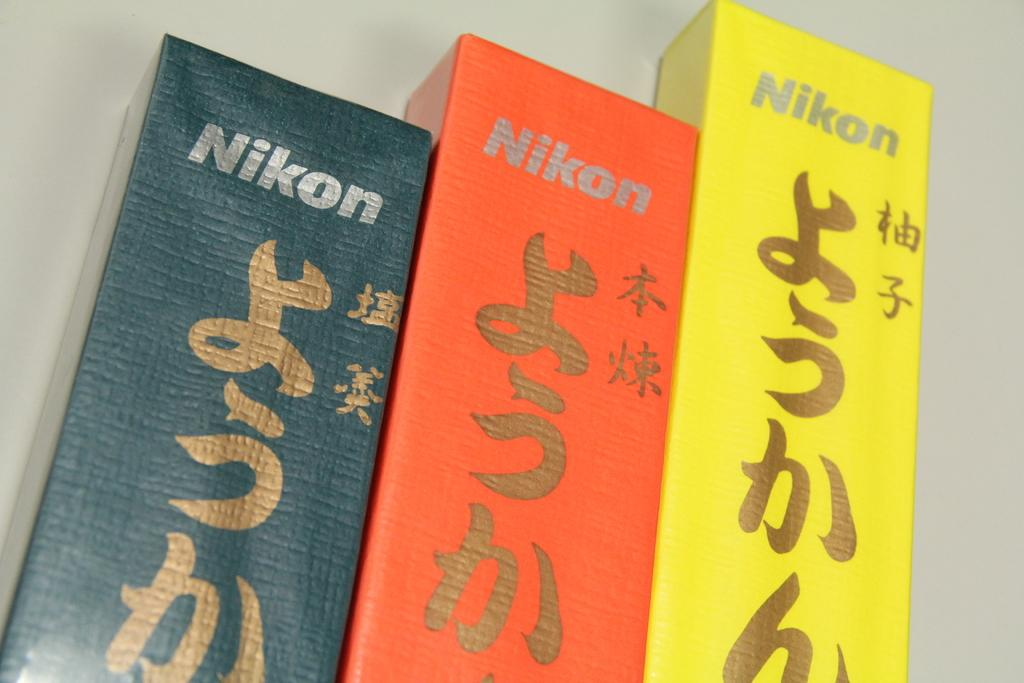<image>
Give a short and clear explanation of the subsequent image. Green, orange, and yellow boxes are lined up and have Nikon logos on them. 